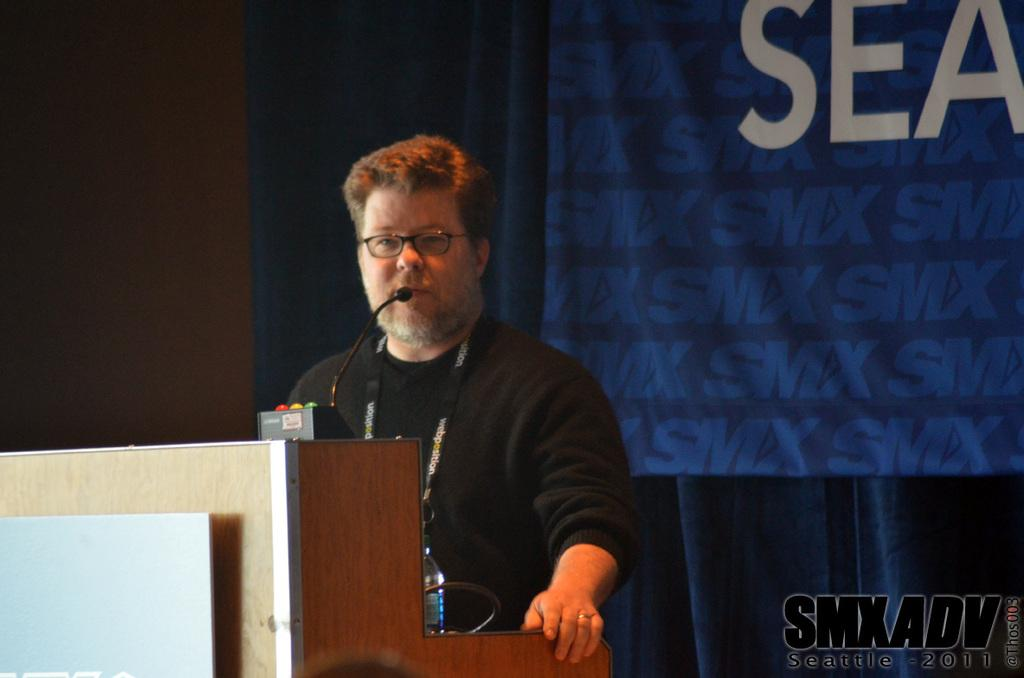What is the person standing near in the image? The person is standing near a speaker's desk. What can be found on the speaker's desk? The speaker's desk contains a mic and a bottle. What is visible on the backside of the image? There is a curtain visible on the backside. How many feet are visible in the image? There is no mention of feet or any body parts in the image; it only shows a person standing near a speaker's desk. 